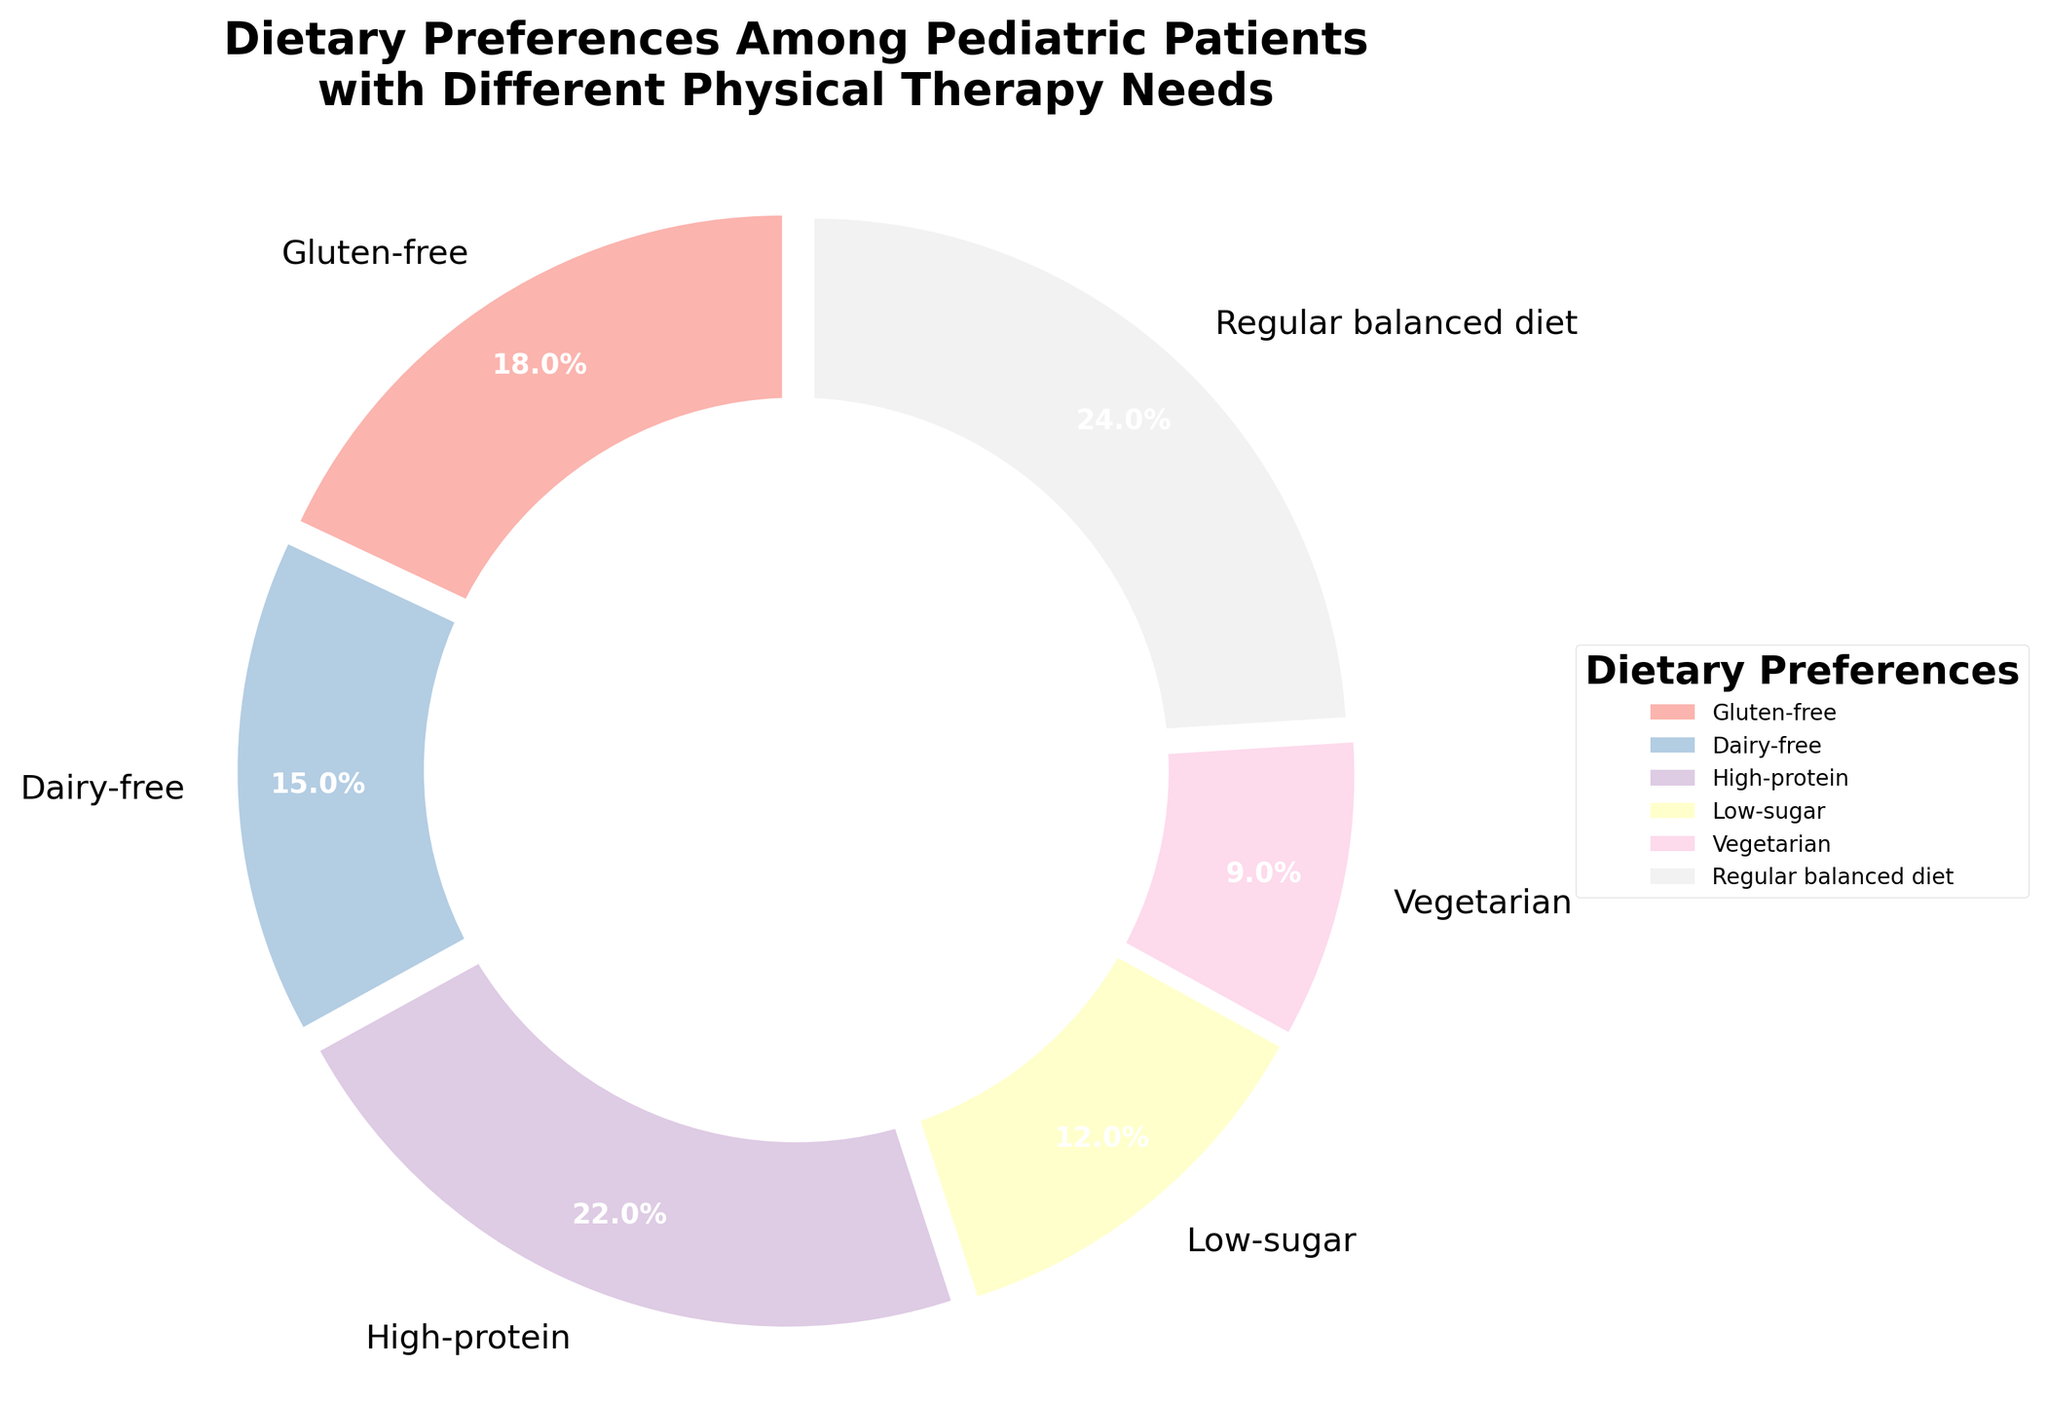What is the most common dietary preference among pediatric patients with different physical therapy needs? The pie chart shows the percentage of different dietary preferences. The largest wedge represents the most common preference. “Regular balanced diet” has the largest segment with 24%.
Answer: Regular balanced diet Which dietary preference has the smallest representation among the patients? By examining the pie chart, the smallest wedge indicates the least common preference. The “Vegetarian” wedge is the smallest with 9%.
Answer: Vegetarian What percentage of patients follow a dairy-free diet? The pie chart includes labels with percentages for each dietary preference. The “Dairy-free” label shows 15%.
Answer: 15% How much larger is the percentage of patients following a high-protein diet compared to those on a low-sugar diet? Subtract the percentage for “Low-sugar” (12%) from the percentage for “High-protein” (22%). The difference is 22% - 12% = 10%.
Answer: 10% If you combine the percentages of patients following gluten-free and dairy-free diets, what is the total? Add the percentages for “Gluten-free” (18%) and “Dairy-free” (15%). The total is 18% + 15% = 33%.
Answer: 33% Which dietary preference is more common: low-sugar or vegetarian? Compare the percentages for “Low-sugar” (12%) and “Vegetarian” (9%). Since 12% is greater than 9%, low-sugar is more common.
Answer: Low-sugar What is the combined percentage of patients following either a gluten-free or a high-protein diet? Add the percentages for “Gluten-free” (18%) and “High-protein” (22%). The total is 18% + 22% = 40%.
Answer: 40% Among the dietary preferences represented, which one is more than double the percentage of the vegetarian diet? Check if doubling the vegetarian percentage (9% * 2 = 18%) is less than any other category. The combined high-protein (22%) and regular balanced diet (24%) both exceed this threshold.
Answer: High-protein and Regular balanced diet What percentage of patients do not follow a regular balanced diet? Subtract the percentage of patients on a regular balanced diet (24%) from 100%. The result is 100% - 24% = 76%.
Answer: 76% How does the size of the low-sugar segment compare to the dairy-free segment visually? Visually compare the wedges for “Low-sugar” and “Dairy-free”. The low-sugar segment (12%) is smaller than the dairy-free segment (15%).
Answer: Dairy-free segment is larger 